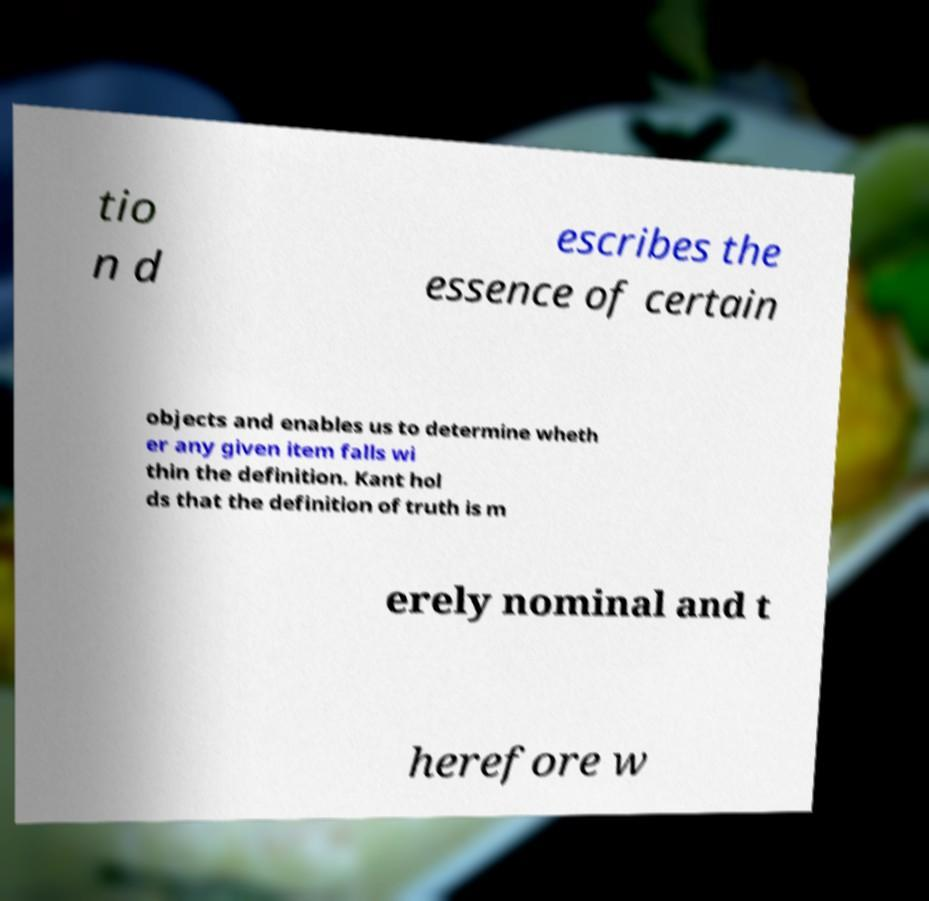What messages or text are displayed in this image? I need them in a readable, typed format. tio n d escribes the essence of certain objects and enables us to determine wheth er any given item falls wi thin the definition. Kant hol ds that the definition of truth is m erely nominal and t herefore w 